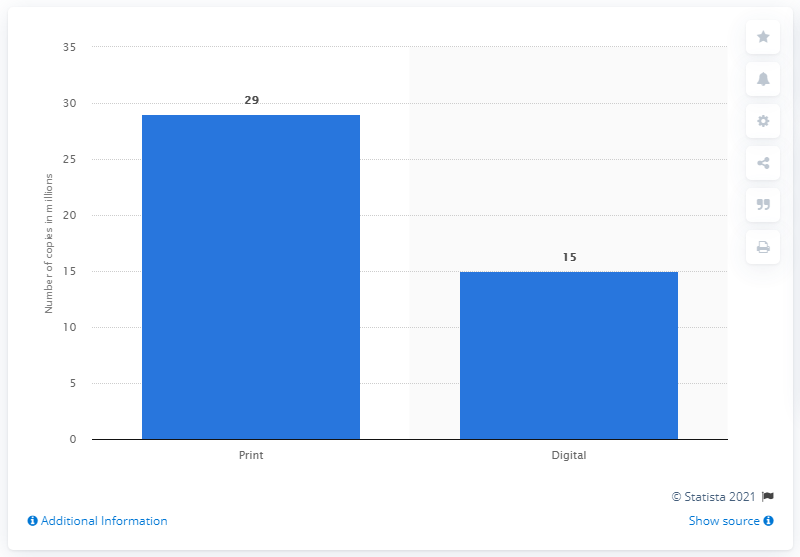Draw attention to some important aspects in this diagram. In 2012, the number of copies of E.L. James' "Fifty Shades of Grey" sold in the United States was higher for print media than for digital media. In 2012, the total number of print copies sold of the novel "50 Shades of Grey" was 29. The total number of copies of "Fifty Shades of Grey" by E.L. James sold in the United States in 2012 was approximately 44 million. In 2012, 50 Shades of Grey sold 15 digital copies. 